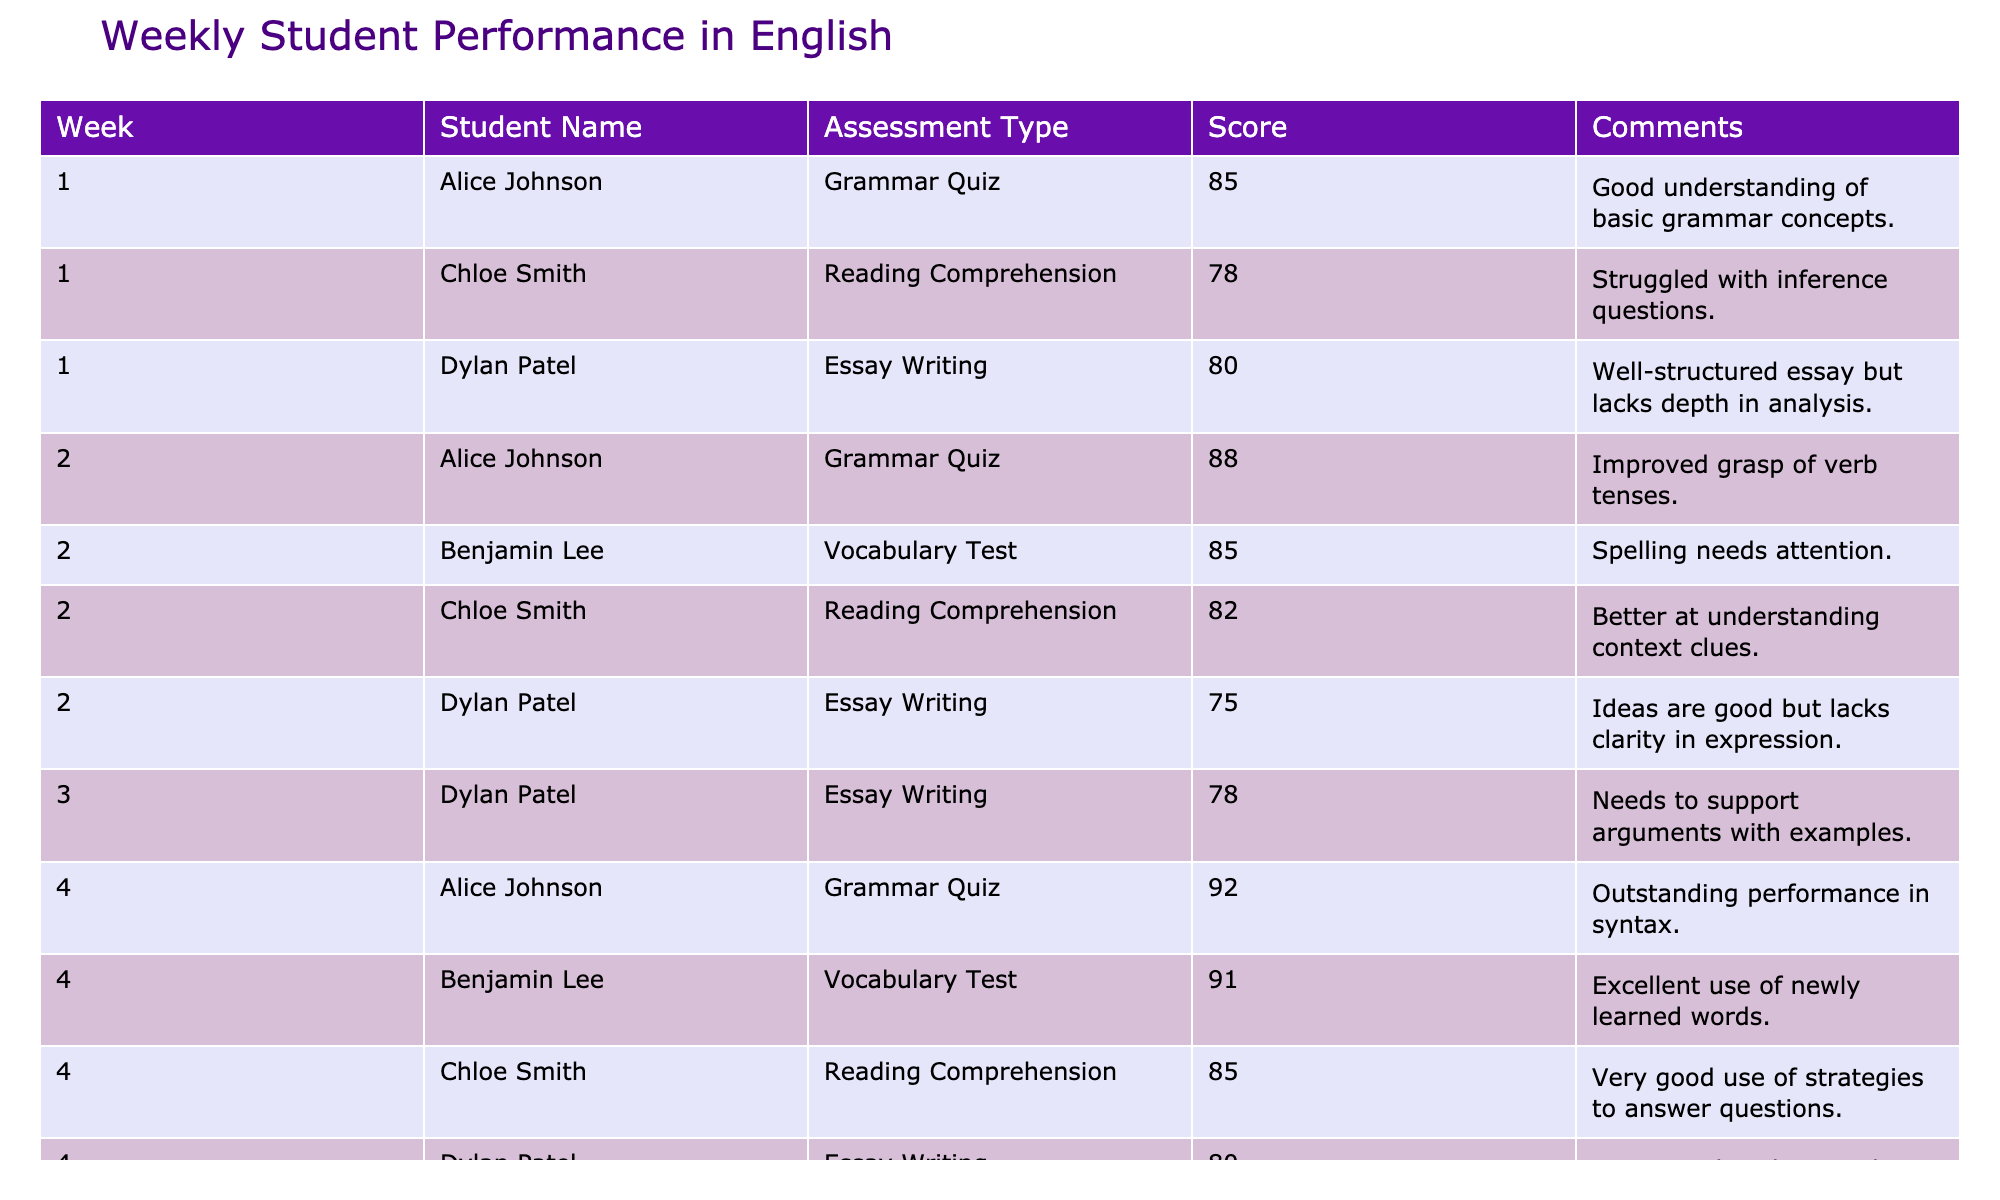What was Alice Johnson's highest score? Looking through the table, Alice's scores are 85, 88, and 92. The highest score among these is 92.
Answer: 92 What is the average score of Chloe Smith across all weeks? Chloe's scores are 78, 82, and 85. Adding these together gives 78 + 82 + 85 = 245. Since she has 3 scores, the average is 245 / 3 = 81.67.
Answer: 81.67 Did Dylan Patel improve his Essay Writing score from week 2 to week 4? Dylan's scores in Essay Writing are 80 (week 1), 75 (week 2), and 80 (week 4). From week 2 to week 4, his score was 75 and then improved to 80, which indicates an improvement.
Answer: Yes What is the difference between Alice Johnson's highest and lowest scores? Alice's scores are 85, 88, and 92. The lowest score is 85 and the highest is 92. The difference is 92 - 85 = 7.
Answer: 7 How many students scored above 80 in Vocabulary Tests? The table shows that only Benjamin Lee scored 85 in week 2 and 91 in week 4. Therefore, we count just 2 instances where he scored above 80.
Answer: 2 What assessment type did Chloe Smith score the lowest? Chloe's scores are 78 (Reading Comprehension), 82 (Reading Comprehension), and 85 (Reading Comprehension). The lowest score is 78 during week 1 in Reading Comprehension.
Answer: Reading Comprehension How many total assessments were recorded for Dylan Patel? Reviewing the table, Dylan Patel has scores in three assessments: two for Essay Writing and none for other subjects across four weeks. Counting these gives a total of 3 assessments.
Answer: 3 Which student had the most assessments listed? By examining the table, it shows that each student had assessments in each of the weeks measured. All students have 3 assessments, therefore they are tied.
Answer: They are tied 